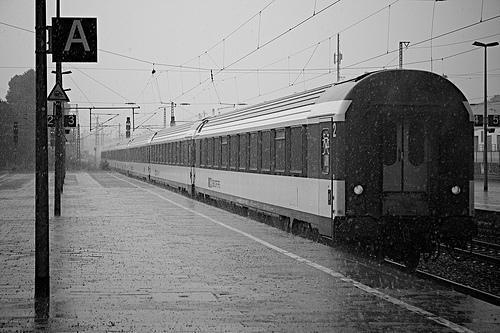How many lights are on the front of the train?
Give a very brief answer. 2. How many doors are visible on the front of the train?
Give a very brief answer. 2. 